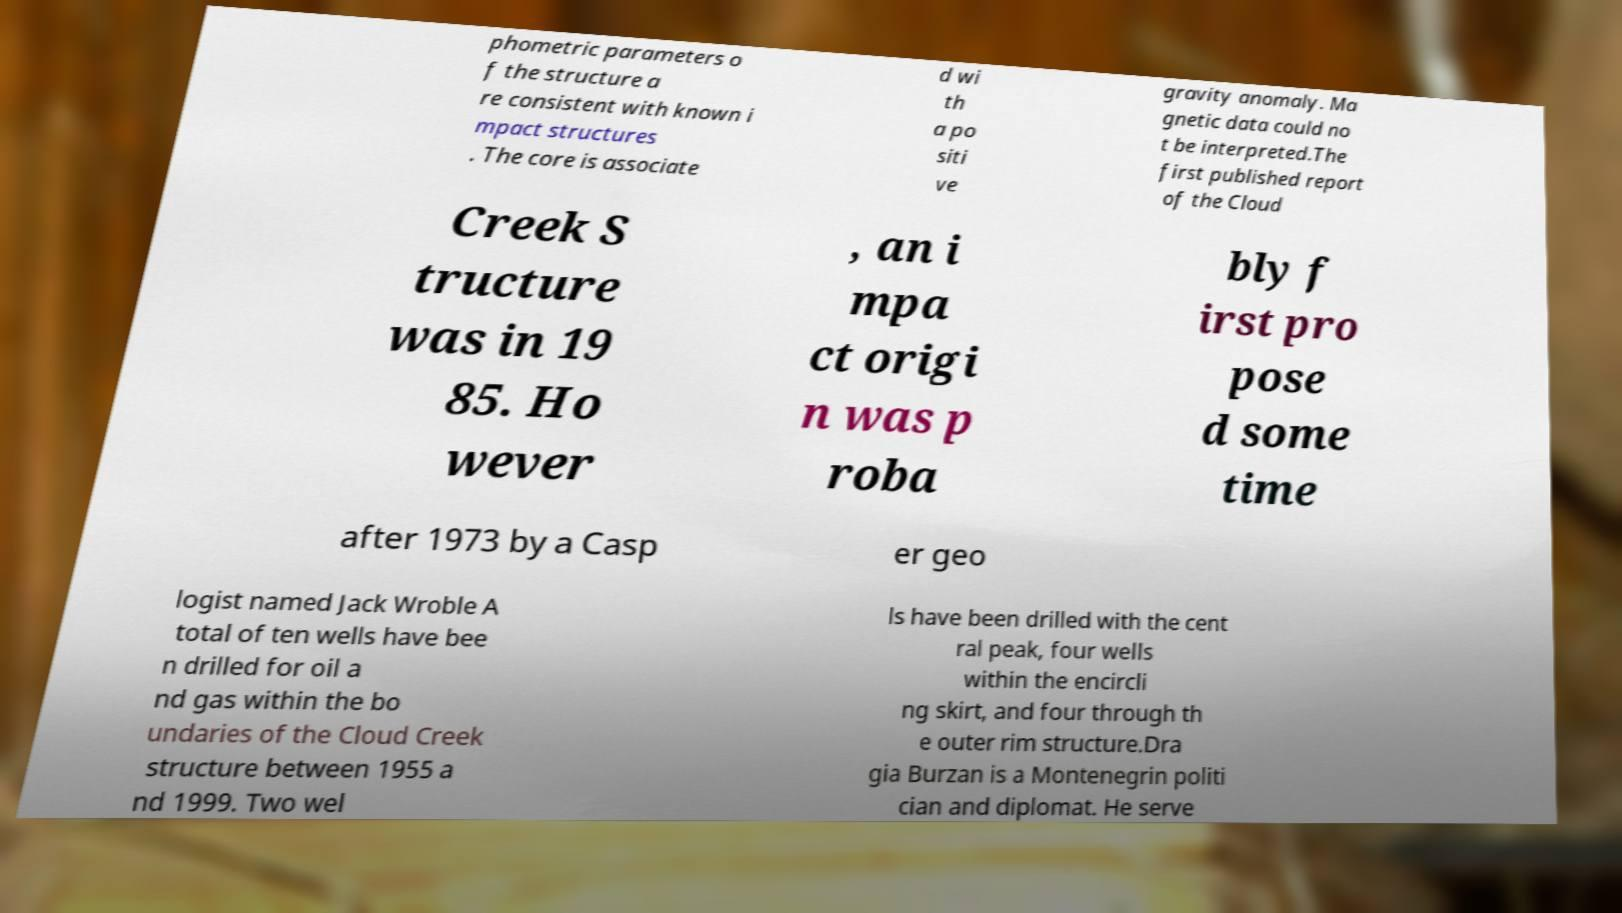Please read and relay the text visible in this image. What does it say? phometric parameters o f the structure a re consistent with known i mpact structures . The core is associate d wi th a po siti ve gravity anomaly. Ma gnetic data could no t be interpreted.The first published report of the Cloud Creek S tructure was in 19 85. Ho wever , an i mpa ct origi n was p roba bly f irst pro pose d some time after 1973 by a Casp er geo logist named Jack Wroble A total of ten wells have bee n drilled for oil a nd gas within the bo undaries of the Cloud Creek structure between 1955 a nd 1999. Two wel ls have been drilled with the cent ral peak, four wells within the encircli ng skirt, and four through th e outer rim structure.Dra gia Burzan is a Montenegrin politi cian and diplomat. He serve 